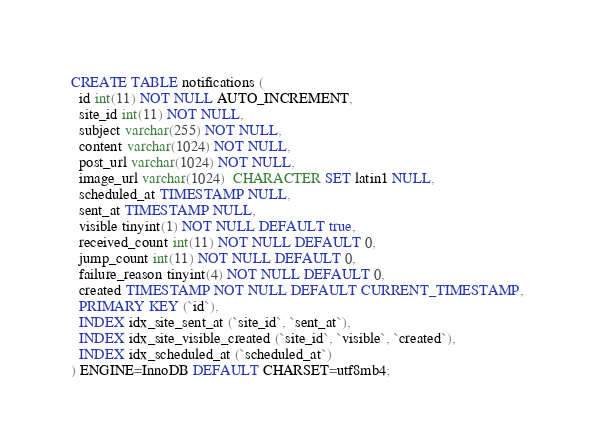<code> <loc_0><loc_0><loc_500><loc_500><_SQL_>CREATE TABLE notifications (
  id int(11) NOT NULL AUTO_INCREMENT,
  site_id int(11) NOT NULL,
  subject varchar(255) NOT NULL,
  content varchar(1024) NOT NULL,
  post_url varchar(1024) NOT NULL,
  image_url varchar(1024)  CHARACTER SET latin1 NULL,
  scheduled_at TIMESTAMP NULL,
  sent_at TIMESTAMP NULL,
  visible tinyint(1) NOT NULL DEFAULT true,
  received_count int(11) NOT NULL DEFAULT 0,
  jump_count int(11) NOT NULL DEFAULT 0,
  failure_reason tinyint(4) NOT NULL DEFAULT 0,
  created TIMESTAMP NOT NULL DEFAULT CURRENT_TIMESTAMP,
  PRIMARY KEY (`id`),
  INDEX idx_site_sent_at (`site_id`, `sent_at`),
  INDEX idx_site_visible_created (`site_id`, `visible`, `created`),
  INDEX idx_scheduled_at (`scheduled_at`)
) ENGINE=InnoDB DEFAULT CHARSET=utf8mb4;

</code> 